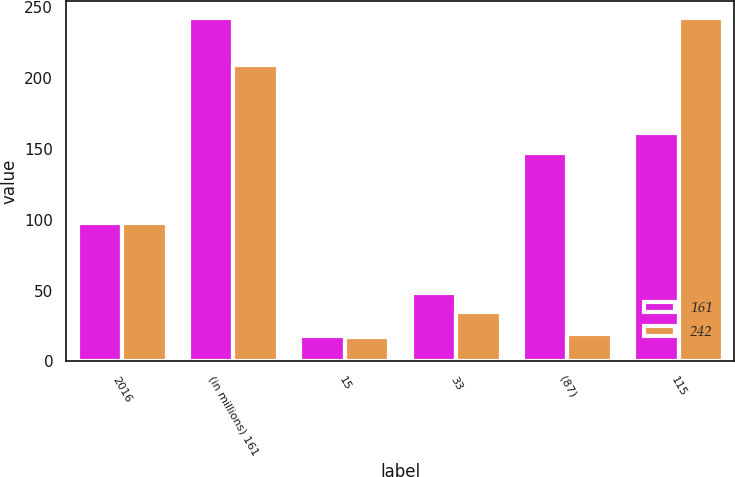Convert chart to OTSL. <chart><loc_0><loc_0><loc_500><loc_500><stacked_bar_chart><ecel><fcel>2016<fcel>(in millions) 161<fcel>15<fcel>33<fcel>(87)<fcel>115<nl><fcel>161<fcel>97.5<fcel>242<fcel>18<fcel>48<fcel>147<fcel>161<nl><fcel>242<fcel>97.5<fcel>209<fcel>17<fcel>35<fcel>19<fcel>242<nl></chart> 